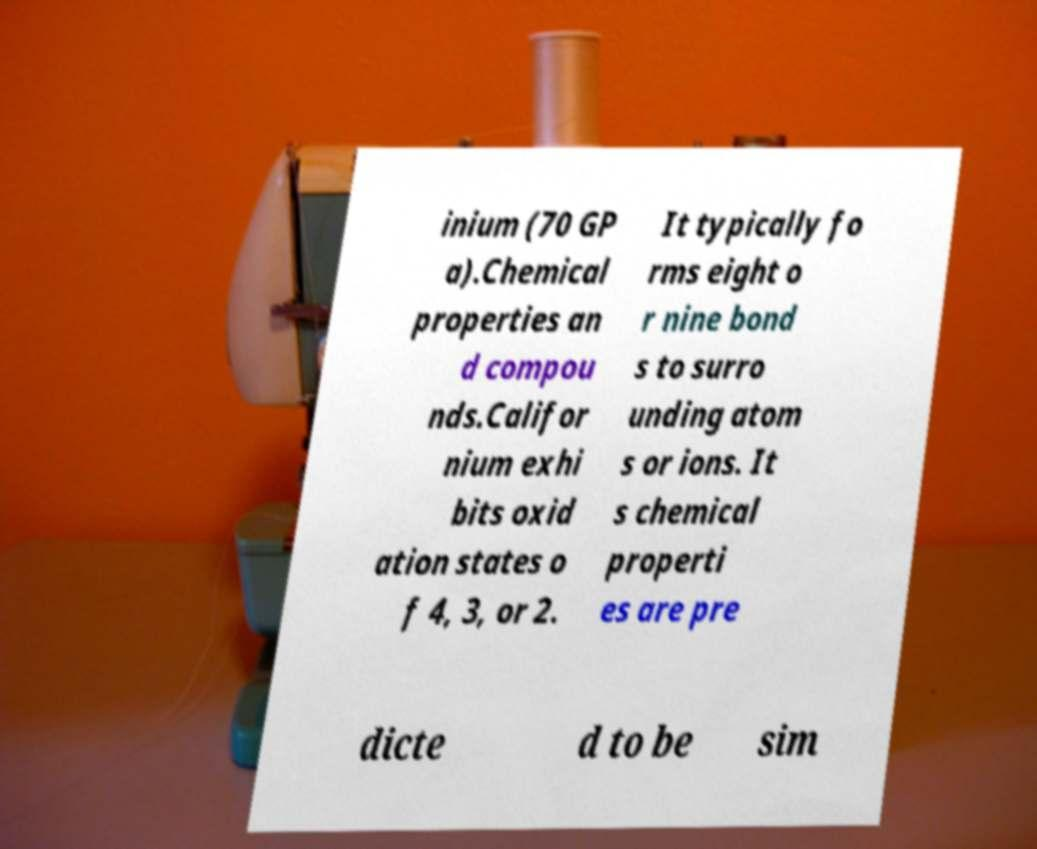I need the written content from this picture converted into text. Can you do that? inium (70 GP a).Chemical properties an d compou nds.Califor nium exhi bits oxid ation states o f 4, 3, or 2. It typically fo rms eight o r nine bond s to surro unding atom s or ions. It s chemical properti es are pre dicte d to be sim 